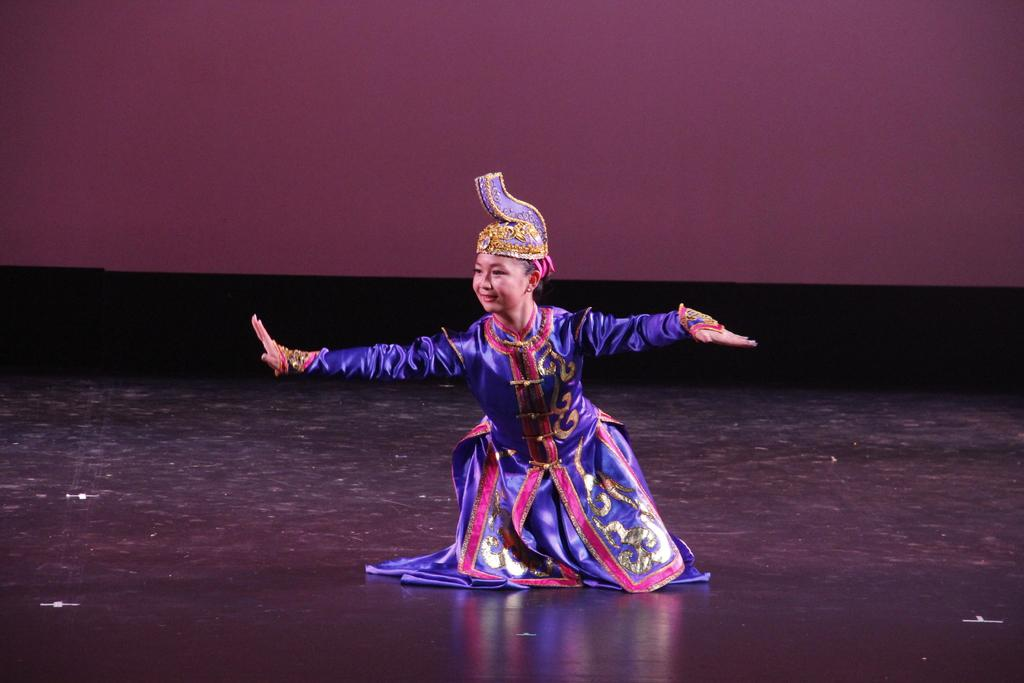Who is the main subject in the image? There is a girl in the image. What is the girl doing in the image? The girl appears to be dancing. How is the girl positioned in the image? The girl is kneeling on the floor. What can be seen in the background of the image? There is a wall in the background of the image. What type of rock is the girl using to dance in the image? There is no rock present in the image; the girl is dancing on the floor. 